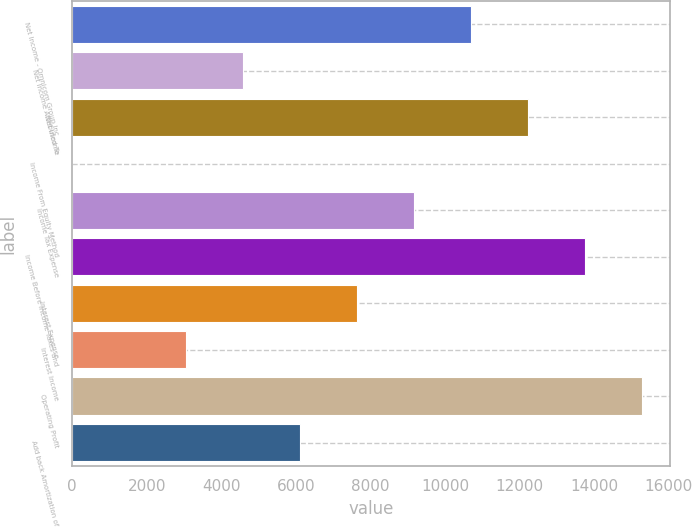Convert chart to OTSL. <chart><loc_0><loc_0><loc_500><loc_500><bar_chart><fcel>Net Income - Omnicom Group Inc<fcel>Net Income Attributed To<fcel>Net Income<fcel>Income From Equity Method<fcel>Income Tax Expense<fcel>Income Before Income Taxes and<fcel>Interest Expense<fcel>Interest Income<fcel>Operating Profit<fcel>Add back Amortization of<nl><fcel>10692.6<fcel>4584.53<fcel>12219.6<fcel>3.5<fcel>9165.56<fcel>13746.6<fcel>7638.55<fcel>3057.52<fcel>15273.6<fcel>6111.54<nl></chart> 